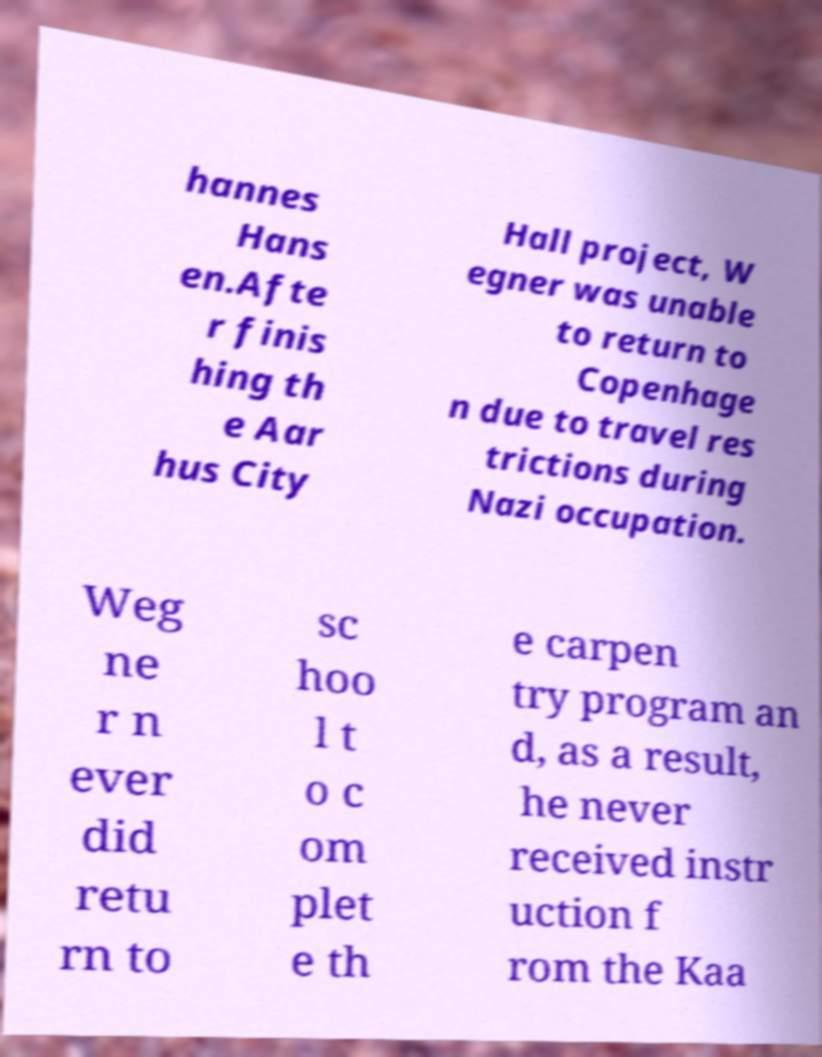Please identify and transcribe the text found in this image. hannes Hans en.Afte r finis hing th e Aar hus City Hall project, W egner was unable to return to Copenhage n due to travel res trictions during Nazi occupation. Weg ne r n ever did retu rn to sc hoo l t o c om plet e th e carpen try program an d, as a result, he never received instr uction f rom the Kaa 